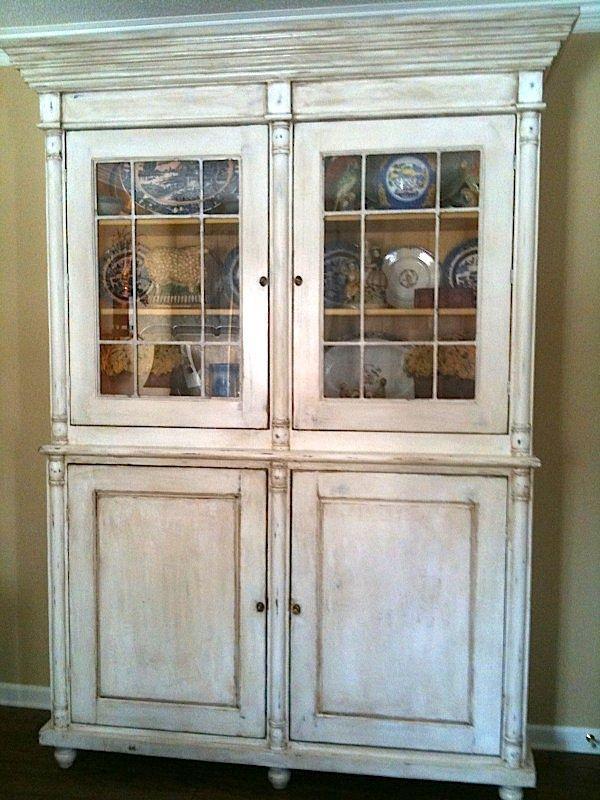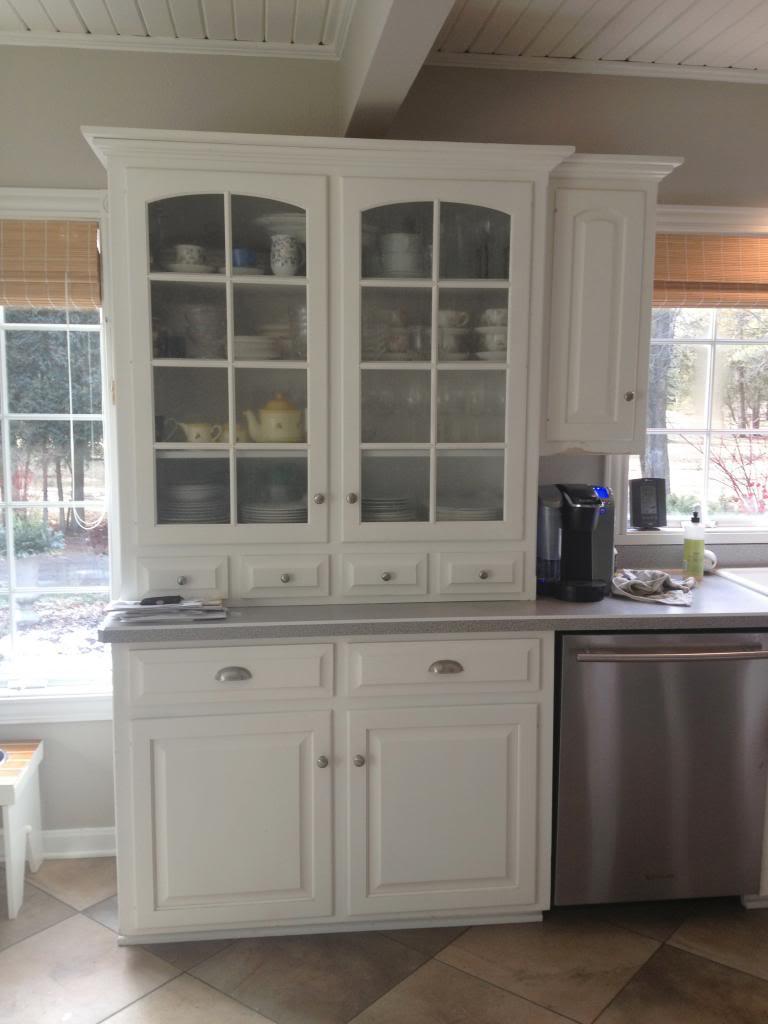The first image is the image on the left, the second image is the image on the right. Given the left and right images, does the statement "There are cabinets with rounded tops" hold true? Answer yes or no. No. The first image is the image on the left, the second image is the image on the right. Examine the images to the left and right. Is the description "All cabinets pictured have flat tops, and the right-hand cabinet sits flush on the floor without legs." accurate? Answer yes or no. Yes. 